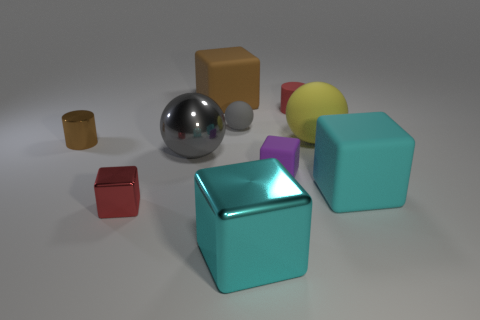Subtract all large rubber cubes. How many cubes are left? 3 Subtract all gray balls. How many cyan cubes are left? 2 Subtract all yellow balls. How many balls are left? 2 Subtract all cylinders. How many objects are left? 8 Subtract 2 blocks. How many blocks are left? 3 Add 7 tiny red cubes. How many tiny red cubes are left? 8 Add 8 gray shiny cubes. How many gray shiny cubes exist? 8 Subtract 1 brown cubes. How many objects are left? 9 Subtract all purple spheres. Subtract all gray cubes. How many spheres are left? 3 Subtract all purple rubber things. Subtract all tiny matte spheres. How many objects are left? 8 